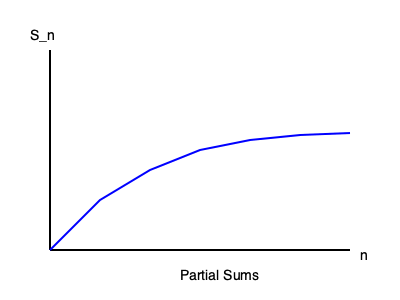Given the graph of partial sums $S_n$ for an infinite series, determine whether the series converges or diverges. If it converges, estimate the sum of the series. To determine the convergence of the infinite series and estimate its sum, we need to analyze the behavior of the partial sums $S_n$ as $n$ approaches infinity. Let's follow these steps:

1. Observe the graph:
   The graph shows the partial sums $S_n$ plotted against $n$.

2. Analyze the trend:
   As $n$ increases, we can see that the values of $S_n$ are increasing but at a decreasing rate.

3. Look for a horizontal asymptote:
   The graph appears to be leveling off and approaching a horizontal asymptote as $n$ increases.

4. Apply the concept of convergence:
   For a series to converge, the sequence of partial sums must have a finite limit as $n$ approaches infinity.

5. Conclusion on convergence:
   Since the graph shows the partial sums approaching a finite value (horizontal asymptote), we can conclude that the series converges.

6. Estimate the sum:
   The sum of the series is the value that the partial sums approach as $n$ approaches infinity. From the graph, we can estimate this value to be approximately 2.7.

Therefore, the series converges, and its sum is approximately 2.7.
Answer: Converges; Sum ≈ 2.7 